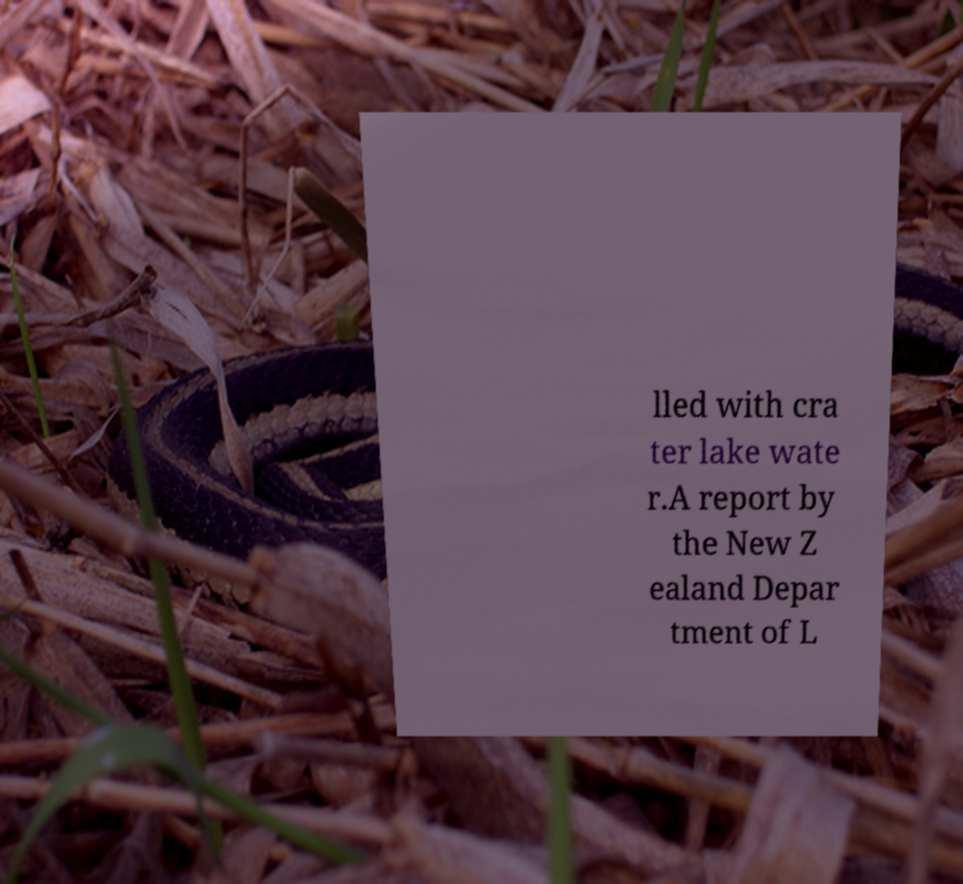Please identify and transcribe the text found in this image. lled with cra ter lake wate r.A report by the New Z ealand Depar tment of L 